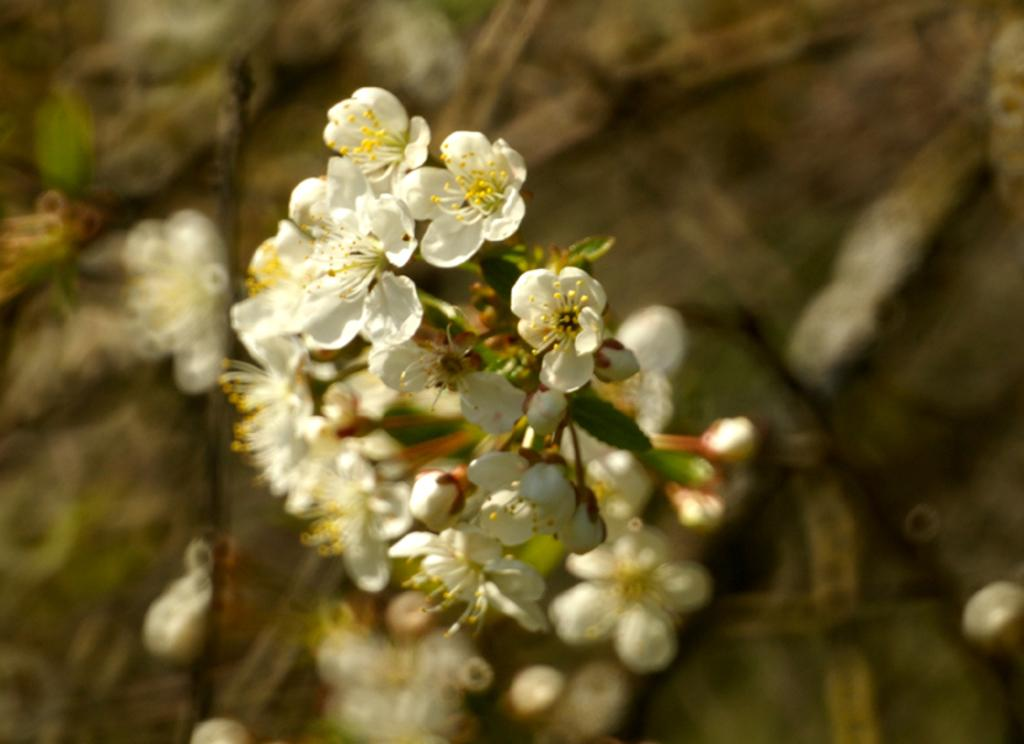What type of living organisms can be seen in the image? There are flowers in the image. Can you describe the background of the image? The background of the image is blurred. What type of shoe is visible in the image? There is no shoe present in the image; it only features flowers and a blurred background. 